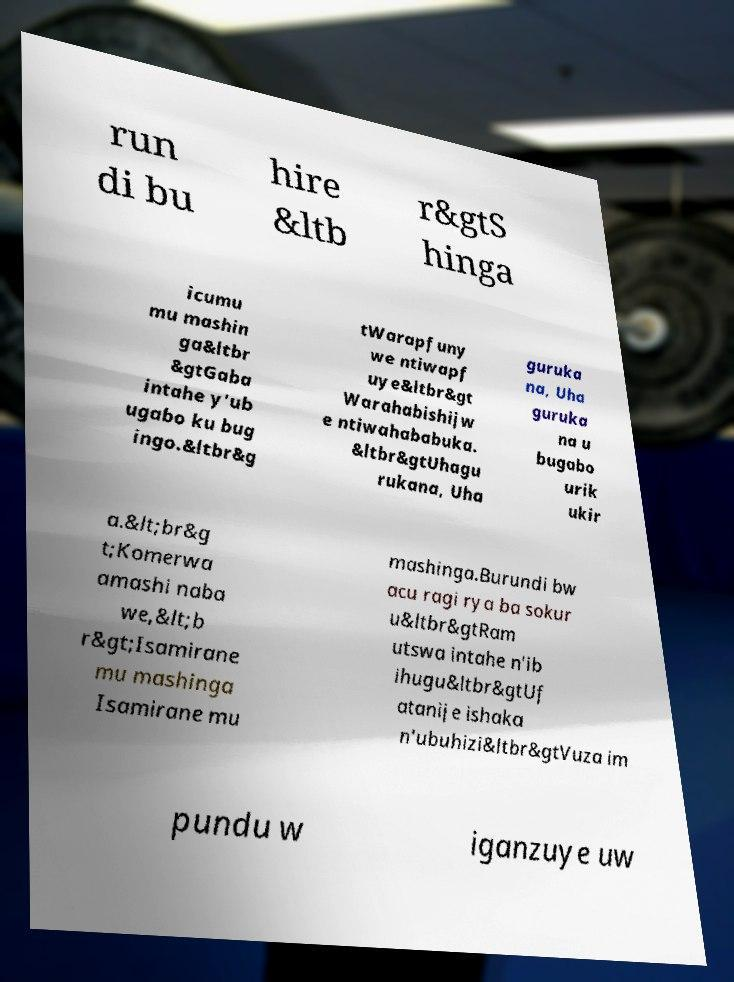Please identify and transcribe the text found in this image. run di bu hire &ltb r&gtS hinga icumu mu mashin ga&ltbr &gtGaba intahe y'ub ugabo ku bug ingo.&ltbr&g tWarapfuny we ntiwapf uye&ltbr&gt Warahabishijw e ntiwahababuka. &ltbr&gtUhagu rukana, Uha guruka na, Uha guruka na u bugabo urik ukir a.&lt;br&g t;Komerwa amashi naba we,&lt;b r&gt;Isamirane mu mashinga Isamirane mu mashinga.Burundi bw acu ragi rya ba sokur u&ltbr&gtRam utswa intahe n'ib ihugu&ltbr&gtUf atanije ishaka n'ubuhizi&ltbr&gtVuza im pundu w iganzuye uw 